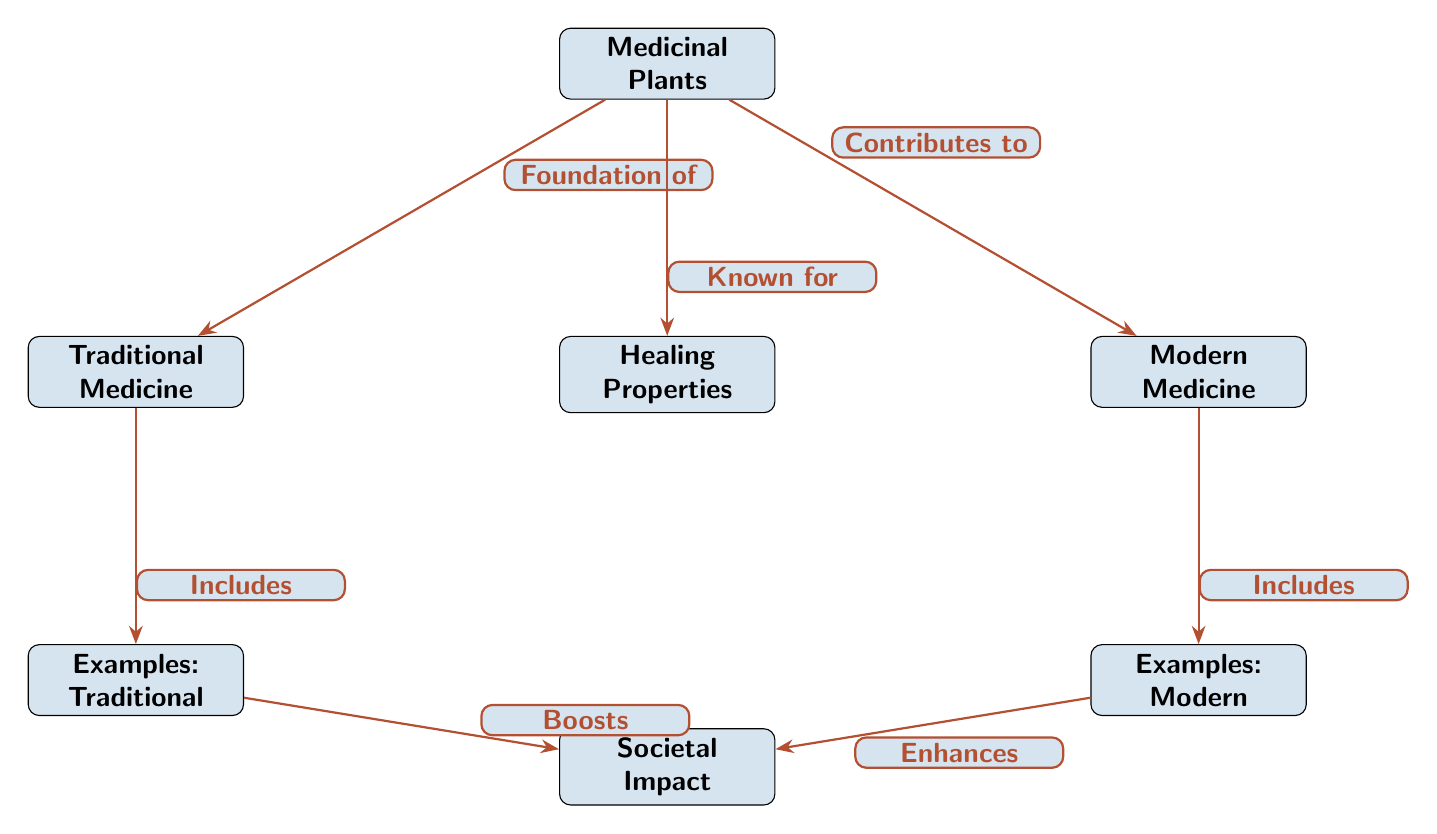What are the two branches of medicine that medicinal plants contribute to? The diagram shows that medicinal plants are foundational to two branches: traditional medicine and modern medicine.
Answer: traditional medicine, modern medicine How many examples of traditional medicine are listed? The diagram contains one node labeled "Examples: Traditional" under the traditional medicine branch, indicating that there is one example of traditional medicine.
Answer: 1 What is the relationship between medicinal plants and healing properties? Medicinal plants are directly connected to healing properties in the diagram, with an edge labeled "Known for" indicating that they are recognized for these properties.
Answer: Known for Which branch of medicine includes examples of modern applications? The modern medicine branch of the diagram specifically indicates that it includes examples labeled "Examples: Modern."
Answer: Examples: Modern How does traditional medicine impact society according to the diagram? The diagram illustrates that traditional medicine, through its examples, boosts societal impact, establishing a connection that indicates a positive effect or enhancement on society.
Answer: Boosts What is the societal impact of medicinal plants as found in modern medicine? The diagram describes that through examples of modern medicine, medicinal plants enhance societal impact, again indicating a beneficial relationship.
Answer: Enhances What element connects the two branches of medicine to their societal impacts? The diagram presents a clear link where both branches of medicine depend on the healing properties of medicinal plants, which in turn influence societal impacts through their specific examples.
Answer: Healing Properties What type of diagram is used to represent the information about medicinal plants? The structure and flow of the information, with nodes and edges indicating relationships, classify this representation as a Natural Science Diagram.
Answer: Natural Science Diagram 